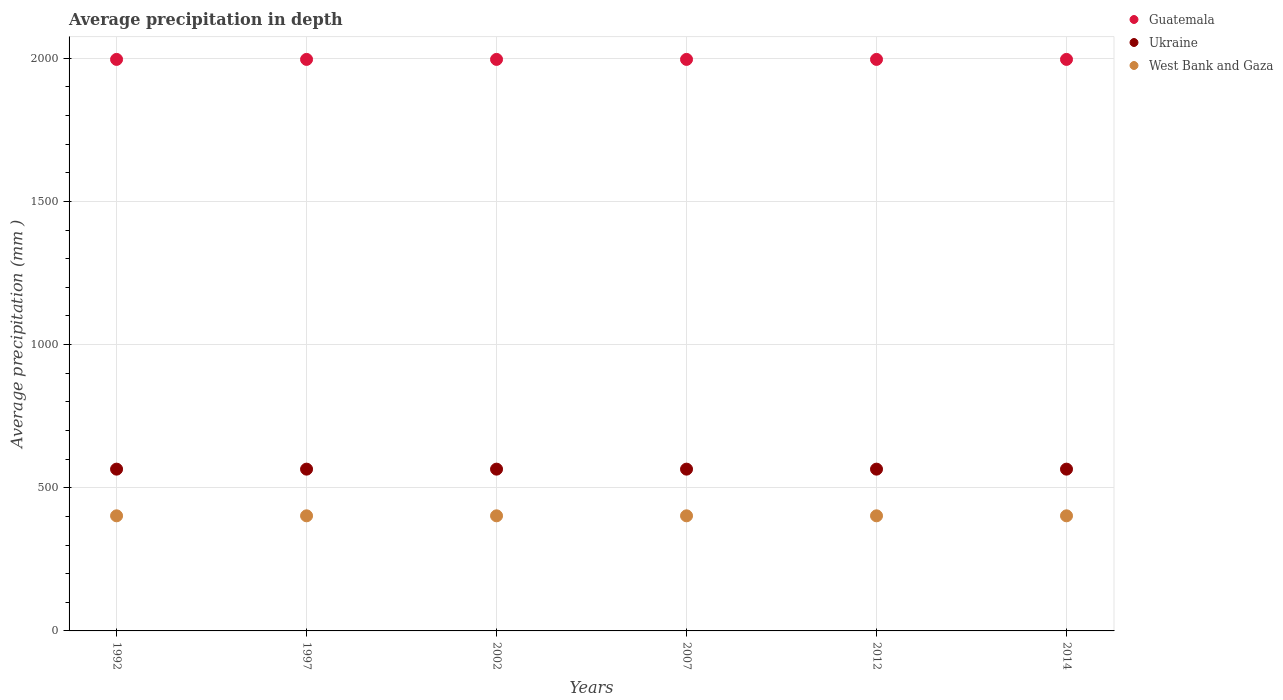Is the number of dotlines equal to the number of legend labels?
Keep it short and to the point. Yes. What is the average precipitation in Ukraine in 2007?
Your answer should be compact. 565. Across all years, what is the maximum average precipitation in Ukraine?
Make the answer very short. 565. In which year was the average precipitation in Guatemala minimum?
Offer a very short reply. 1992. What is the total average precipitation in Ukraine in the graph?
Your answer should be very brief. 3390. What is the difference between the average precipitation in West Bank and Gaza in 1992 and the average precipitation in Ukraine in 2007?
Make the answer very short. -163. What is the average average precipitation in West Bank and Gaza per year?
Offer a terse response. 402. In the year 2014, what is the difference between the average precipitation in Guatemala and average precipitation in Ukraine?
Offer a terse response. 1431. What is the ratio of the average precipitation in Guatemala in 1992 to that in 2002?
Give a very brief answer. 1. Is the average precipitation in Guatemala in 2002 less than that in 2014?
Ensure brevity in your answer.  No. Is the difference between the average precipitation in Guatemala in 2007 and 2012 greater than the difference between the average precipitation in Ukraine in 2007 and 2012?
Your answer should be compact. No. What is the difference between the highest and the second highest average precipitation in Ukraine?
Ensure brevity in your answer.  0. Is it the case that in every year, the sum of the average precipitation in West Bank and Gaza and average precipitation in Guatemala  is greater than the average precipitation in Ukraine?
Provide a short and direct response. Yes. Is the average precipitation in Ukraine strictly greater than the average precipitation in West Bank and Gaza over the years?
Your answer should be compact. Yes. Is the average precipitation in Ukraine strictly less than the average precipitation in Guatemala over the years?
Offer a terse response. Yes. How many years are there in the graph?
Provide a short and direct response. 6. Where does the legend appear in the graph?
Your response must be concise. Top right. How many legend labels are there?
Make the answer very short. 3. What is the title of the graph?
Your response must be concise. Average precipitation in depth. Does "High income" appear as one of the legend labels in the graph?
Your answer should be compact. No. What is the label or title of the Y-axis?
Keep it short and to the point. Average precipitation (mm ). What is the Average precipitation (mm ) in Guatemala in 1992?
Your answer should be compact. 1996. What is the Average precipitation (mm ) of Ukraine in 1992?
Give a very brief answer. 565. What is the Average precipitation (mm ) of West Bank and Gaza in 1992?
Your response must be concise. 402. What is the Average precipitation (mm ) in Guatemala in 1997?
Keep it short and to the point. 1996. What is the Average precipitation (mm ) of Ukraine in 1997?
Provide a short and direct response. 565. What is the Average precipitation (mm ) of West Bank and Gaza in 1997?
Your response must be concise. 402. What is the Average precipitation (mm ) in Guatemala in 2002?
Your answer should be very brief. 1996. What is the Average precipitation (mm ) in Ukraine in 2002?
Your answer should be compact. 565. What is the Average precipitation (mm ) of West Bank and Gaza in 2002?
Provide a short and direct response. 402. What is the Average precipitation (mm ) in Guatemala in 2007?
Your answer should be very brief. 1996. What is the Average precipitation (mm ) in Ukraine in 2007?
Your answer should be compact. 565. What is the Average precipitation (mm ) of West Bank and Gaza in 2007?
Offer a very short reply. 402. What is the Average precipitation (mm ) of Guatemala in 2012?
Your response must be concise. 1996. What is the Average precipitation (mm ) in Ukraine in 2012?
Your response must be concise. 565. What is the Average precipitation (mm ) in West Bank and Gaza in 2012?
Provide a short and direct response. 402. What is the Average precipitation (mm ) of Guatemala in 2014?
Offer a terse response. 1996. What is the Average precipitation (mm ) of Ukraine in 2014?
Your answer should be compact. 565. What is the Average precipitation (mm ) of West Bank and Gaza in 2014?
Make the answer very short. 402. Across all years, what is the maximum Average precipitation (mm ) in Guatemala?
Provide a short and direct response. 1996. Across all years, what is the maximum Average precipitation (mm ) of Ukraine?
Provide a short and direct response. 565. Across all years, what is the maximum Average precipitation (mm ) of West Bank and Gaza?
Offer a terse response. 402. Across all years, what is the minimum Average precipitation (mm ) of Guatemala?
Provide a short and direct response. 1996. Across all years, what is the minimum Average precipitation (mm ) in Ukraine?
Keep it short and to the point. 565. Across all years, what is the minimum Average precipitation (mm ) in West Bank and Gaza?
Provide a succinct answer. 402. What is the total Average precipitation (mm ) of Guatemala in the graph?
Your response must be concise. 1.20e+04. What is the total Average precipitation (mm ) in Ukraine in the graph?
Your answer should be compact. 3390. What is the total Average precipitation (mm ) in West Bank and Gaza in the graph?
Your answer should be compact. 2412. What is the difference between the Average precipitation (mm ) of West Bank and Gaza in 1992 and that in 1997?
Ensure brevity in your answer.  0. What is the difference between the Average precipitation (mm ) of Ukraine in 1992 and that in 2002?
Make the answer very short. 0. What is the difference between the Average precipitation (mm ) in West Bank and Gaza in 1992 and that in 2012?
Provide a succinct answer. 0. What is the difference between the Average precipitation (mm ) of Guatemala in 1992 and that in 2014?
Your answer should be very brief. 0. What is the difference between the Average precipitation (mm ) in Ukraine in 1992 and that in 2014?
Make the answer very short. 0. What is the difference between the Average precipitation (mm ) of Guatemala in 1997 and that in 2002?
Offer a very short reply. 0. What is the difference between the Average precipitation (mm ) in Ukraine in 1997 and that in 2002?
Offer a very short reply. 0. What is the difference between the Average precipitation (mm ) of West Bank and Gaza in 1997 and that in 2002?
Your answer should be very brief. 0. What is the difference between the Average precipitation (mm ) in Guatemala in 1997 and that in 2007?
Your answer should be compact. 0. What is the difference between the Average precipitation (mm ) in Ukraine in 1997 and that in 2007?
Ensure brevity in your answer.  0. What is the difference between the Average precipitation (mm ) of Ukraine in 1997 and that in 2012?
Your answer should be compact. 0. What is the difference between the Average precipitation (mm ) of West Bank and Gaza in 1997 and that in 2012?
Your answer should be very brief. 0. What is the difference between the Average precipitation (mm ) in Ukraine in 1997 and that in 2014?
Give a very brief answer. 0. What is the difference between the Average precipitation (mm ) of West Bank and Gaza in 1997 and that in 2014?
Ensure brevity in your answer.  0. What is the difference between the Average precipitation (mm ) in Ukraine in 2002 and that in 2007?
Your response must be concise. 0. What is the difference between the Average precipitation (mm ) in Guatemala in 2002 and that in 2012?
Offer a very short reply. 0. What is the difference between the Average precipitation (mm ) of Guatemala in 2002 and that in 2014?
Ensure brevity in your answer.  0. What is the difference between the Average precipitation (mm ) in West Bank and Gaza in 2002 and that in 2014?
Offer a very short reply. 0. What is the difference between the Average precipitation (mm ) in Guatemala in 2012 and that in 2014?
Make the answer very short. 0. What is the difference between the Average precipitation (mm ) in Ukraine in 2012 and that in 2014?
Your answer should be very brief. 0. What is the difference between the Average precipitation (mm ) of West Bank and Gaza in 2012 and that in 2014?
Provide a succinct answer. 0. What is the difference between the Average precipitation (mm ) of Guatemala in 1992 and the Average precipitation (mm ) of Ukraine in 1997?
Keep it short and to the point. 1431. What is the difference between the Average precipitation (mm ) of Guatemala in 1992 and the Average precipitation (mm ) of West Bank and Gaza in 1997?
Provide a short and direct response. 1594. What is the difference between the Average precipitation (mm ) of Ukraine in 1992 and the Average precipitation (mm ) of West Bank and Gaza in 1997?
Provide a succinct answer. 163. What is the difference between the Average precipitation (mm ) of Guatemala in 1992 and the Average precipitation (mm ) of Ukraine in 2002?
Your response must be concise. 1431. What is the difference between the Average precipitation (mm ) of Guatemala in 1992 and the Average precipitation (mm ) of West Bank and Gaza in 2002?
Make the answer very short. 1594. What is the difference between the Average precipitation (mm ) in Ukraine in 1992 and the Average precipitation (mm ) in West Bank and Gaza in 2002?
Offer a very short reply. 163. What is the difference between the Average precipitation (mm ) in Guatemala in 1992 and the Average precipitation (mm ) in Ukraine in 2007?
Your answer should be very brief. 1431. What is the difference between the Average precipitation (mm ) of Guatemala in 1992 and the Average precipitation (mm ) of West Bank and Gaza in 2007?
Keep it short and to the point. 1594. What is the difference between the Average precipitation (mm ) of Ukraine in 1992 and the Average precipitation (mm ) of West Bank and Gaza in 2007?
Ensure brevity in your answer.  163. What is the difference between the Average precipitation (mm ) in Guatemala in 1992 and the Average precipitation (mm ) in Ukraine in 2012?
Your answer should be very brief. 1431. What is the difference between the Average precipitation (mm ) of Guatemala in 1992 and the Average precipitation (mm ) of West Bank and Gaza in 2012?
Keep it short and to the point. 1594. What is the difference between the Average precipitation (mm ) of Ukraine in 1992 and the Average precipitation (mm ) of West Bank and Gaza in 2012?
Your answer should be very brief. 163. What is the difference between the Average precipitation (mm ) of Guatemala in 1992 and the Average precipitation (mm ) of Ukraine in 2014?
Provide a succinct answer. 1431. What is the difference between the Average precipitation (mm ) of Guatemala in 1992 and the Average precipitation (mm ) of West Bank and Gaza in 2014?
Provide a succinct answer. 1594. What is the difference between the Average precipitation (mm ) in Ukraine in 1992 and the Average precipitation (mm ) in West Bank and Gaza in 2014?
Give a very brief answer. 163. What is the difference between the Average precipitation (mm ) of Guatemala in 1997 and the Average precipitation (mm ) of Ukraine in 2002?
Keep it short and to the point. 1431. What is the difference between the Average precipitation (mm ) of Guatemala in 1997 and the Average precipitation (mm ) of West Bank and Gaza in 2002?
Give a very brief answer. 1594. What is the difference between the Average precipitation (mm ) of Ukraine in 1997 and the Average precipitation (mm ) of West Bank and Gaza in 2002?
Your answer should be compact. 163. What is the difference between the Average precipitation (mm ) in Guatemala in 1997 and the Average precipitation (mm ) in Ukraine in 2007?
Provide a succinct answer. 1431. What is the difference between the Average precipitation (mm ) in Guatemala in 1997 and the Average precipitation (mm ) in West Bank and Gaza in 2007?
Give a very brief answer. 1594. What is the difference between the Average precipitation (mm ) in Ukraine in 1997 and the Average precipitation (mm ) in West Bank and Gaza in 2007?
Your response must be concise. 163. What is the difference between the Average precipitation (mm ) in Guatemala in 1997 and the Average precipitation (mm ) in Ukraine in 2012?
Make the answer very short. 1431. What is the difference between the Average precipitation (mm ) in Guatemala in 1997 and the Average precipitation (mm ) in West Bank and Gaza in 2012?
Provide a short and direct response. 1594. What is the difference between the Average precipitation (mm ) of Ukraine in 1997 and the Average precipitation (mm ) of West Bank and Gaza in 2012?
Offer a terse response. 163. What is the difference between the Average precipitation (mm ) in Guatemala in 1997 and the Average precipitation (mm ) in Ukraine in 2014?
Your answer should be compact. 1431. What is the difference between the Average precipitation (mm ) in Guatemala in 1997 and the Average precipitation (mm ) in West Bank and Gaza in 2014?
Give a very brief answer. 1594. What is the difference between the Average precipitation (mm ) of Ukraine in 1997 and the Average precipitation (mm ) of West Bank and Gaza in 2014?
Your answer should be very brief. 163. What is the difference between the Average precipitation (mm ) of Guatemala in 2002 and the Average precipitation (mm ) of Ukraine in 2007?
Keep it short and to the point. 1431. What is the difference between the Average precipitation (mm ) of Guatemala in 2002 and the Average precipitation (mm ) of West Bank and Gaza in 2007?
Your answer should be very brief. 1594. What is the difference between the Average precipitation (mm ) in Ukraine in 2002 and the Average precipitation (mm ) in West Bank and Gaza in 2007?
Ensure brevity in your answer.  163. What is the difference between the Average precipitation (mm ) in Guatemala in 2002 and the Average precipitation (mm ) in Ukraine in 2012?
Your response must be concise. 1431. What is the difference between the Average precipitation (mm ) of Guatemala in 2002 and the Average precipitation (mm ) of West Bank and Gaza in 2012?
Keep it short and to the point. 1594. What is the difference between the Average precipitation (mm ) of Ukraine in 2002 and the Average precipitation (mm ) of West Bank and Gaza in 2012?
Provide a succinct answer. 163. What is the difference between the Average precipitation (mm ) in Guatemala in 2002 and the Average precipitation (mm ) in Ukraine in 2014?
Your answer should be very brief. 1431. What is the difference between the Average precipitation (mm ) of Guatemala in 2002 and the Average precipitation (mm ) of West Bank and Gaza in 2014?
Give a very brief answer. 1594. What is the difference between the Average precipitation (mm ) in Ukraine in 2002 and the Average precipitation (mm ) in West Bank and Gaza in 2014?
Your answer should be very brief. 163. What is the difference between the Average precipitation (mm ) of Guatemala in 2007 and the Average precipitation (mm ) of Ukraine in 2012?
Your answer should be very brief. 1431. What is the difference between the Average precipitation (mm ) of Guatemala in 2007 and the Average precipitation (mm ) of West Bank and Gaza in 2012?
Provide a short and direct response. 1594. What is the difference between the Average precipitation (mm ) in Ukraine in 2007 and the Average precipitation (mm ) in West Bank and Gaza in 2012?
Offer a very short reply. 163. What is the difference between the Average precipitation (mm ) of Guatemala in 2007 and the Average precipitation (mm ) of Ukraine in 2014?
Make the answer very short. 1431. What is the difference between the Average precipitation (mm ) in Guatemala in 2007 and the Average precipitation (mm ) in West Bank and Gaza in 2014?
Ensure brevity in your answer.  1594. What is the difference between the Average precipitation (mm ) of Ukraine in 2007 and the Average precipitation (mm ) of West Bank and Gaza in 2014?
Your response must be concise. 163. What is the difference between the Average precipitation (mm ) of Guatemala in 2012 and the Average precipitation (mm ) of Ukraine in 2014?
Offer a terse response. 1431. What is the difference between the Average precipitation (mm ) of Guatemala in 2012 and the Average precipitation (mm ) of West Bank and Gaza in 2014?
Make the answer very short. 1594. What is the difference between the Average precipitation (mm ) of Ukraine in 2012 and the Average precipitation (mm ) of West Bank and Gaza in 2014?
Offer a terse response. 163. What is the average Average precipitation (mm ) of Guatemala per year?
Provide a short and direct response. 1996. What is the average Average precipitation (mm ) of Ukraine per year?
Your answer should be very brief. 565. What is the average Average precipitation (mm ) in West Bank and Gaza per year?
Keep it short and to the point. 402. In the year 1992, what is the difference between the Average precipitation (mm ) in Guatemala and Average precipitation (mm ) in Ukraine?
Keep it short and to the point. 1431. In the year 1992, what is the difference between the Average precipitation (mm ) in Guatemala and Average precipitation (mm ) in West Bank and Gaza?
Ensure brevity in your answer.  1594. In the year 1992, what is the difference between the Average precipitation (mm ) in Ukraine and Average precipitation (mm ) in West Bank and Gaza?
Offer a very short reply. 163. In the year 1997, what is the difference between the Average precipitation (mm ) of Guatemala and Average precipitation (mm ) of Ukraine?
Offer a terse response. 1431. In the year 1997, what is the difference between the Average precipitation (mm ) of Guatemala and Average precipitation (mm ) of West Bank and Gaza?
Provide a short and direct response. 1594. In the year 1997, what is the difference between the Average precipitation (mm ) in Ukraine and Average precipitation (mm ) in West Bank and Gaza?
Provide a short and direct response. 163. In the year 2002, what is the difference between the Average precipitation (mm ) of Guatemala and Average precipitation (mm ) of Ukraine?
Keep it short and to the point. 1431. In the year 2002, what is the difference between the Average precipitation (mm ) in Guatemala and Average precipitation (mm ) in West Bank and Gaza?
Your answer should be compact. 1594. In the year 2002, what is the difference between the Average precipitation (mm ) in Ukraine and Average precipitation (mm ) in West Bank and Gaza?
Make the answer very short. 163. In the year 2007, what is the difference between the Average precipitation (mm ) in Guatemala and Average precipitation (mm ) in Ukraine?
Make the answer very short. 1431. In the year 2007, what is the difference between the Average precipitation (mm ) of Guatemala and Average precipitation (mm ) of West Bank and Gaza?
Your response must be concise. 1594. In the year 2007, what is the difference between the Average precipitation (mm ) in Ukraine and Average precipitation (mm ) in West Bank and Gaza?
Offer a terse response. 163. In the year 2012, what is the difference between the Average precipitation (mm ) of Guatemala and Average precipitation (mm ) of Ukraine?
Provide a short and direct response. 1431. In the year 2012, what is the difference between the Average precipitation (mm ) in Guatemala and Average precipitation (mm ) in West Bank and Gaza?
Provide a short and direct response. 1594. In the year 2012, what is the difference between the Average precipitation (mm ) in Ukraine and Average precipitation (mm ) in West Bank and Gaza?
Your response must be concise. 163. In the year 2014, what is the difference between the Average precipitation (mm ) in Guatemala and Average precipitation (mm ) in Ukraine?
Your answer should be compact. 1431. In the year 2014, what is the difference between the Average precipitation (mm ) of Guatemala and Average precipitation (mm ) of West Bank and Gaza?
Provide a succinct answer. 1594. In the year 2014, what is the difference between the Average precipitation (mm ) in Ukraine and Average precipitation (mm ) in West Bank and Gaza?
Offer a terse response. 163. What is the ratio of the Average precipitation (mm ) of Guatemala in 1992 to that in 1997?
Give a very brief answer. 1. What is the ratio of the Average precipitation (mm ) in West Bank and Gaza in 1992 to that in 1997?
Ensure brevity in your answer.  1. What is the ratio of the Average precipitation (mm ) of Ukraine in 1992 to that in 2002?
Ensure brevity in your answer.  1. What is the ratio of the Average precipitation (mm ) in West Bank and Gaza in 1992 to that in 2002?
Provide a short and direct response. 1. What is the ratio of the Average precipitation (mm ) in West Bank and Gaza in 1992 to that in 2007?
Provide a short and direct response. 1. What is the ratio of the Average precipitation (mm ) in Ukraine in 1992 to that in 2012?
Your response must be concise. 1. What is the ratio of the Average precipitation (mm ) in Ukraine in 1992 to that in 2014?
Provide a short and direct response. 1. What is the ratio of the Average precipitation (mm ) in Guatemala in 1997 to that in 2002?
Make the answer very short. 1. What is the ratio of the Average precipitation (mm ) of Ukraine in 1997 to that in 2002?
Ensure brevity in your answer.  1. What is the ratio of the Average precipitation (mm ) in Guatemala in 1997 to that in 2007?
Ensure brevity in your answer.  1. What is the ratio of the Average precipitation (mm ) in Ukraine in 1997 to that in 2007?
Provide a succinct answer. 1. What is the ratio of the Average precipitation (mm ) of Ukraine in 1997 to that in 2014?
Offer a very short reply. 1. What is the ratio of the Average precipitation (mm ) in West Bank and Gaza in 1997 to that in 2014?
Provide a succinct answer. 1. What is the ratio of the Average precipitation (mm ) of Guatemala in 2002 to that in 2007?
Ensure brevity in your answer.  1. What is the ratio of the Average precipitation (mm ) of West Bank and Gaza in 2002 to that in 2007?
Your answer should be compact. 1. What is the ratio of the Average precipitation (mm ) of Guatemala in 2002 to that in 2012?
Provide a short and direct response. 1. What is the ratio of the Average precipitation (mm ) of Ukraine in 2002 to that in 2014?
Offer a terse response. 1. What is the ratio of the Average precipitation (mm ) in West Bank and Gaza in 2002 to that in 2014?
Offer a very short reply. 1. What is the ratio of the Average precipitation (mm ) in Guatemala in 2007 to that in 2012?
Make the answer very short. 1. What is the ratio of the Average precipitation (mm ) of Ukraine in 2007 to that in 2012?
Make the answer very short. 1. What is the ratio of the Average precipitation (mm ) of West Bank and Gaza in 2007 to that in 2012?
Your answer should be very brief. 1. What is the ratio of the Average precipitation (mm ) in Guatemala in 2007 to that in 2014?
Provide a short and direct response. 1. What is the ratio of the Average precipitation (mm ) in Ukraine in 2007 to that in 2014?
Keep it short and to the point. 1. What is the ratio of the Average precipitation (mm ) of West Bank and Gaza in 2007 to that in 2014?
Make the answer very short. 1. What is the ratio of the Average precipitation (mm ) of Ukraine in 2012 to that in 2014?
Keep it short and to the point. 1. What is the ratio of the Average precipitation (mm ) in West Bank and Gaza in 2012 to that in 2014?
Give a very brief answer. 1. What is the difference between the highest and the second highest Average precipitation (mm ) in Guatemala?
Provide a short and direct response. 0. What is the difference between the highest and the second highest Average precipitation (mm ) in Ukraine?
Ensure brevity in your answer.  0. What is the difference between the highest and the lowest Average precipitation (mm ) in Guatemala?
Provide a short and direct response. 0. What is the difference between the highest and the lowest Average precipitation (mm ) in Ukraine?
Give a very brief answer. 0. 